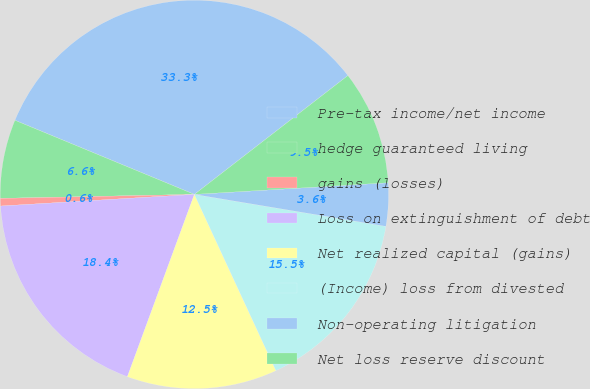Convert chart to OTSL. <chart><loc_0><loc_0><loc_500><loc_500><pie_chart><fcel>Pre-tax income/net income<fcel>hedge guaranteed living<fcel>gains (losses)<fcel>Loss on extinguishment of debt<fcel>Net realized capital (gains)<fcel>(Income) loss from divested<fcel>Non-operating litigation<fcel>Net loss reserve discount<nl><fcel>33.28%<fcel>6.56%<fcel>0.63%<fcel>18.44%<fcel>12.5%<fcel>15.47%<fcel>3.59%<fcel>9.53%<nl></chart> 